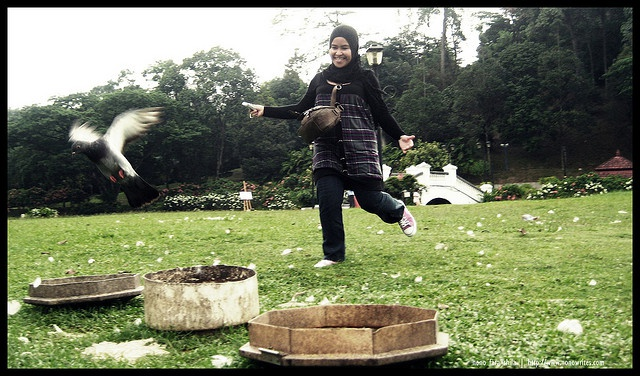Describe the objects in this image and their specific colors. I can see people in black, gray, white, and darkgray tones, bird in black, ivory, gray, and darkgray tones, and handbag in black and gray tones in this image. 